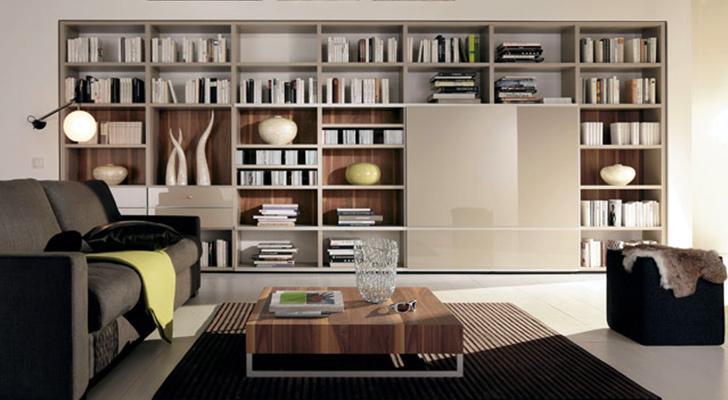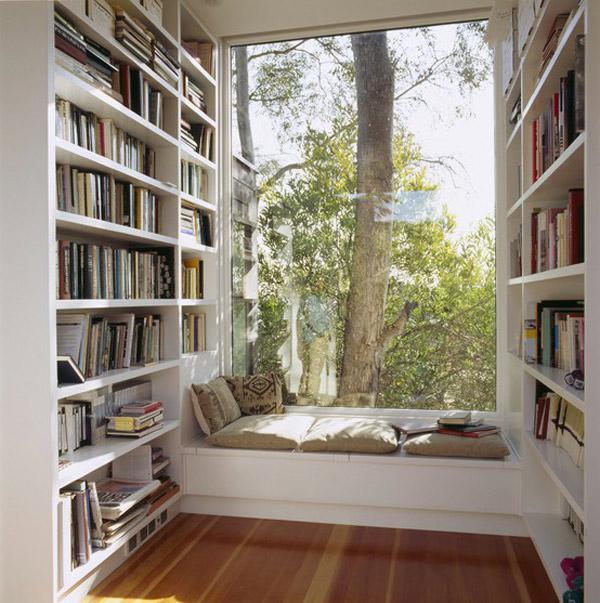The first image is the image on the left, the second image is the image on the right. Examine the images to the left and right. Is the description "In one image, white bookshelves run parallel on opposing walls." accurate? Answer yes or no. Yes. The first image is the image on the left, the second image is the image on the right. Analyze the images presented: Is the assertion "One image shows bookcases lining the left and right walls, with a floor between." valid? Answer yes or no. Yes. 